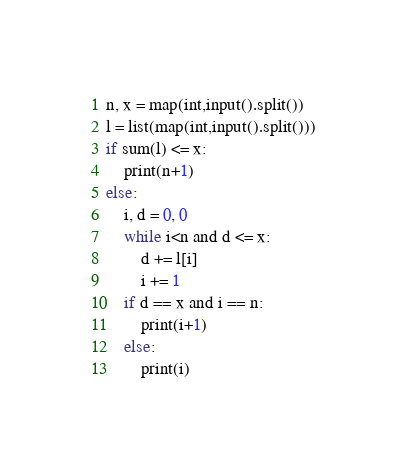<code> <loc_0><loc_0><loc_500><loc_500><_Python_>n, x = map(int,input().split())
l = list(map(int,input().split()))
if sum(l) <= x:
    print(n+1)
else:
    i, d = 0, 0
    while i<n and d <= x:
        d += l[i]
        i += 1
    if d == x and i == n:
        print(i+1)
    else:
        print(i)</code> 